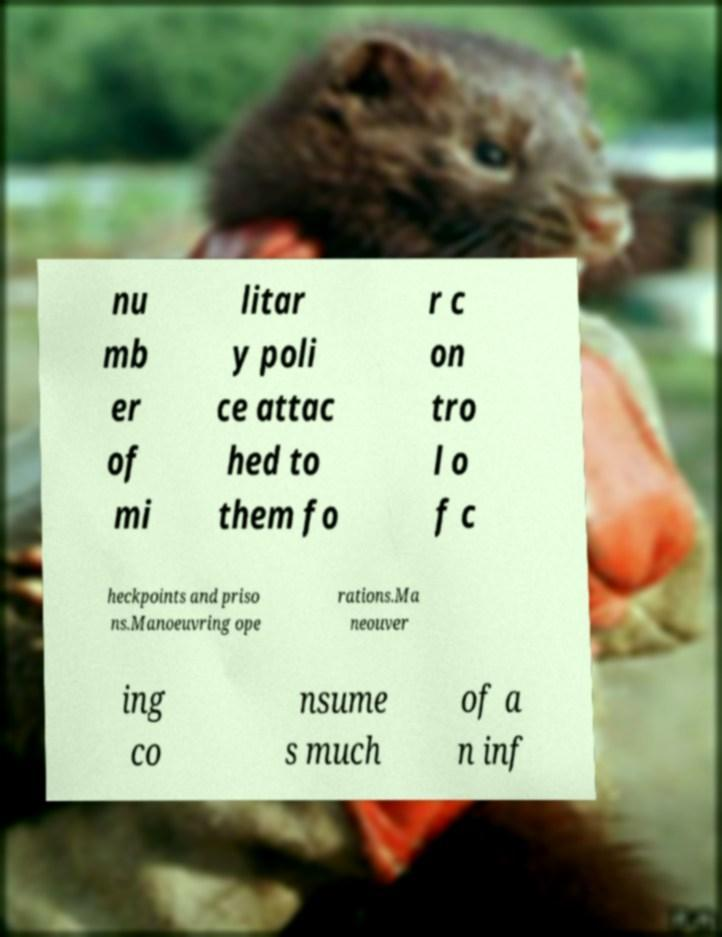Please read and relay the text visible in this image. What does it say? nu mb er of mi litar y poli ce attac hed to them fo r c on tro l o f c heckpoints and priso ns.Manoeuvring ope rations.Ma neouver ing co nsume s much of a n inf 